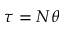<formula> <loc_0><loc_0><loc_500><loc_500>\tau = N \theta</formula> 